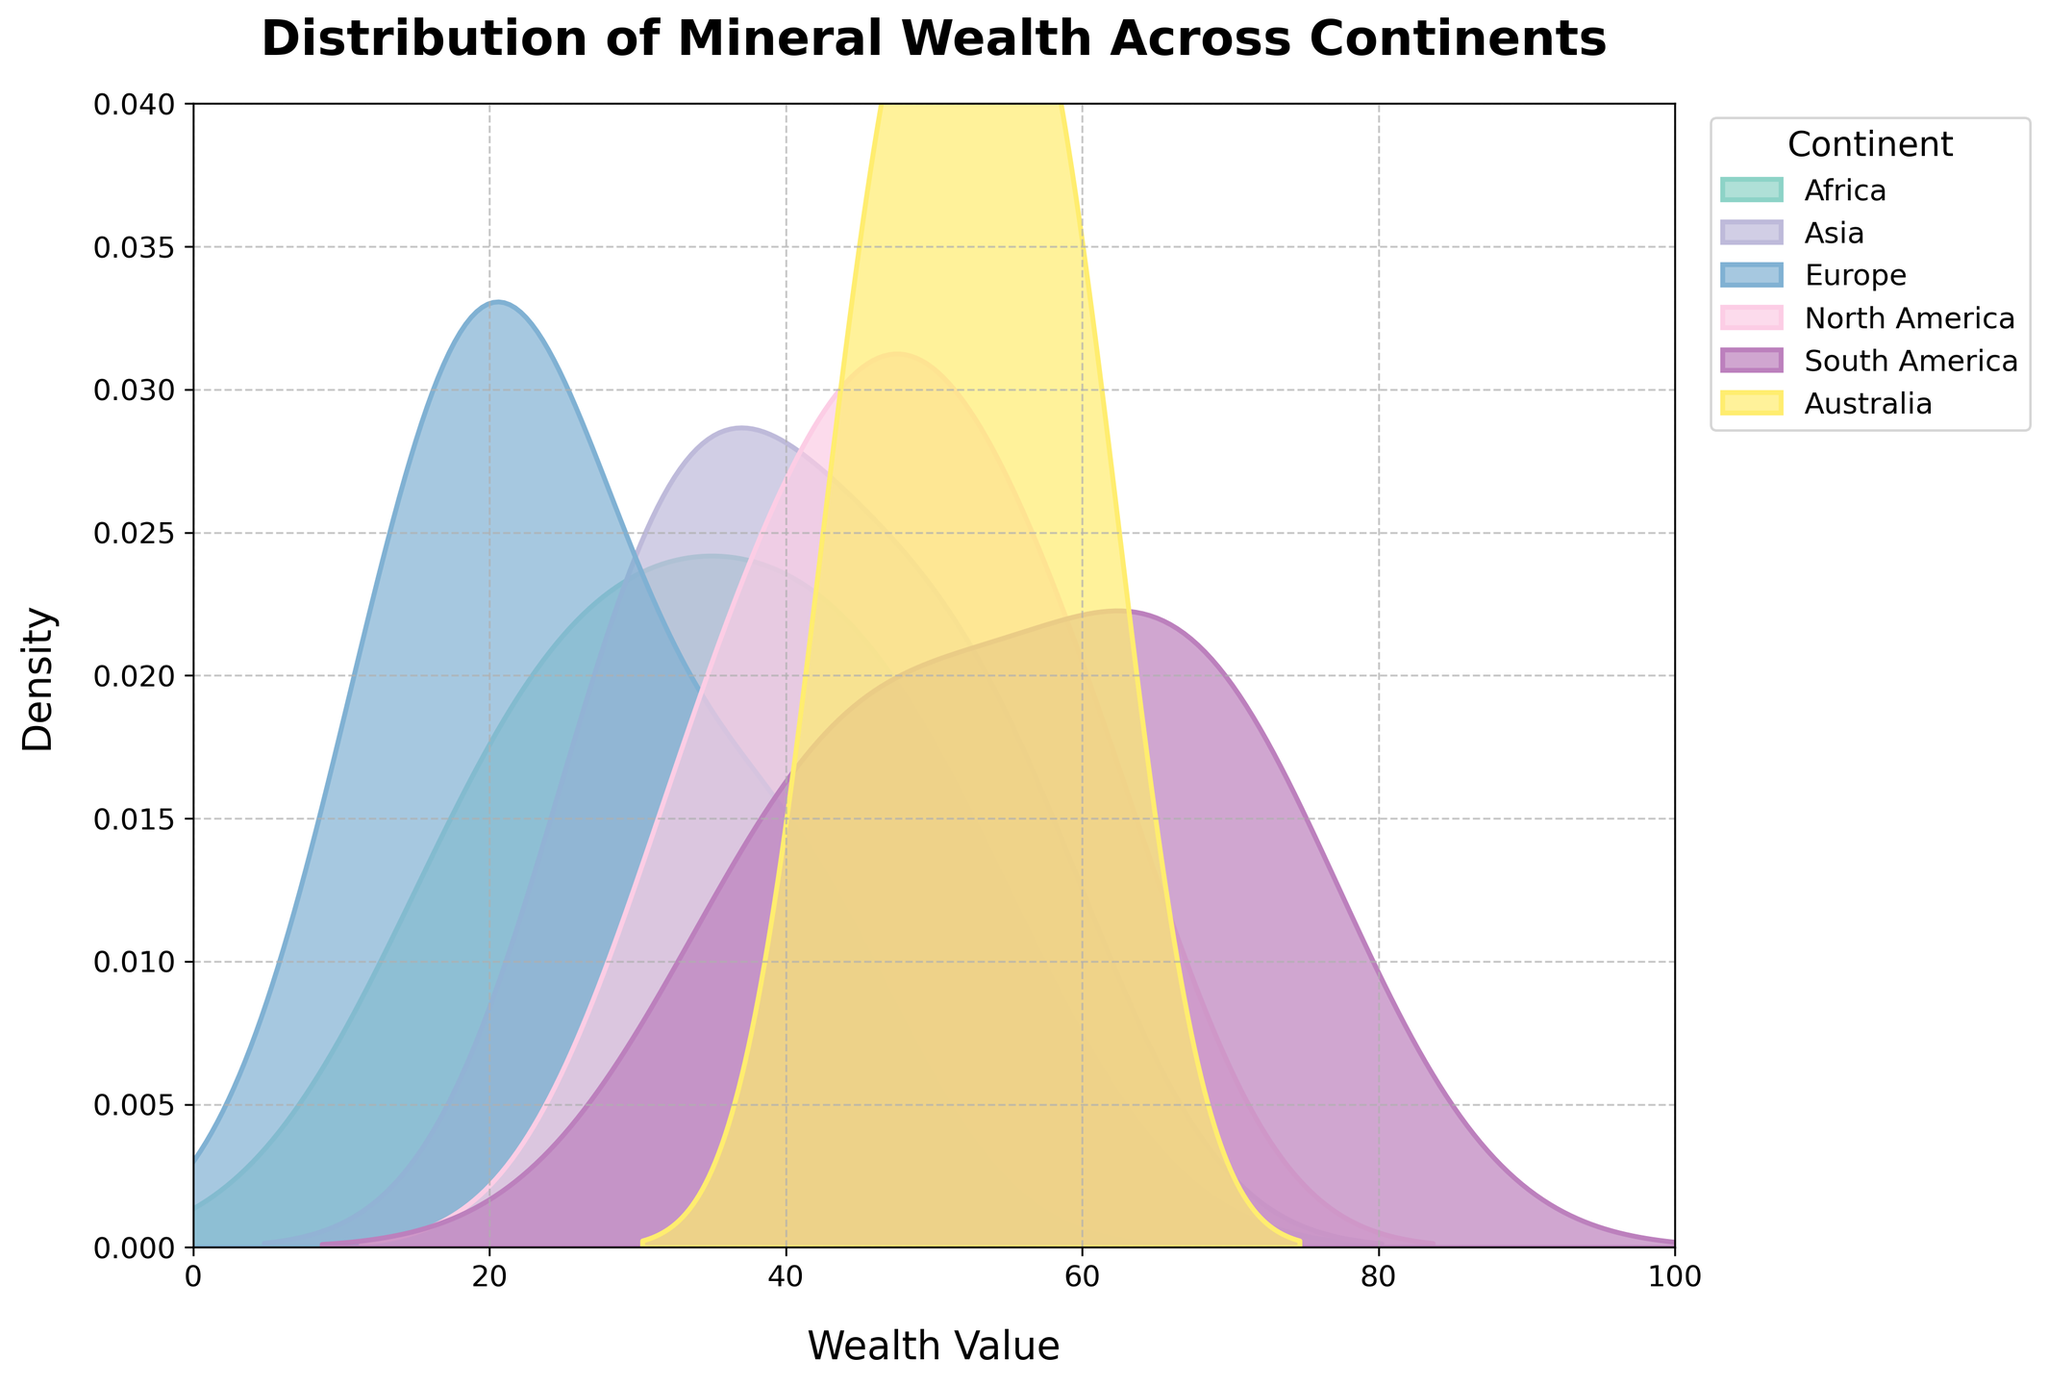what data is plotted on the x-axis? The x-axis represents the wealth value of minerals in different continents. This can be identified by the label "Wealth Value" on the x-axis of the plot.
Answer: wealth value what information is provided by the y-axis? The y-axis displays the density of the wealth values. This can be inferred from the label "Density" on the y-axis of the plot.
Answer: density which continent shows the highest peak in the density plot? Observing the peaks of the density curves in the figure reveals that South America shows the highest peak.
Answer: South America which continent has the widest distribution of mineral wealth? The width of the density curve represents the spread of the data. By comparing the width, Africa appears to have the widest distribution of wealth values.
Answer: Africa is there any continent with a wealth value concentrated around a specific range? South America shows a high density peak, indicating a concentration of wealth values around a specific range. The peak appears around 65 to 70.
Answer: Yes, South America which continent has the lowest density peak? By comparing the heights of the peaks in the density plot, Europe has the lowest density peak.
Answer: Europe how do Africa's and Asia's wealth value distributions compare? Comparing Africa's and Asia's density curves, Africa's distribution is wider and less peaked, while Asia's distribution is more concentrated.
Answer: Africa is wider, Asia is more concentrated are there any continents with overlapping wealth value distributions? The density curves for Asia and Africa have significant overlap, indicating similar ranges of wealth values.
Answer: Yes, Asia and Africa what is the range of wealth values for North America? The density curve for North America spans approximately from 35 to 60 as seen by the plot.
Answer: 35 to 60 